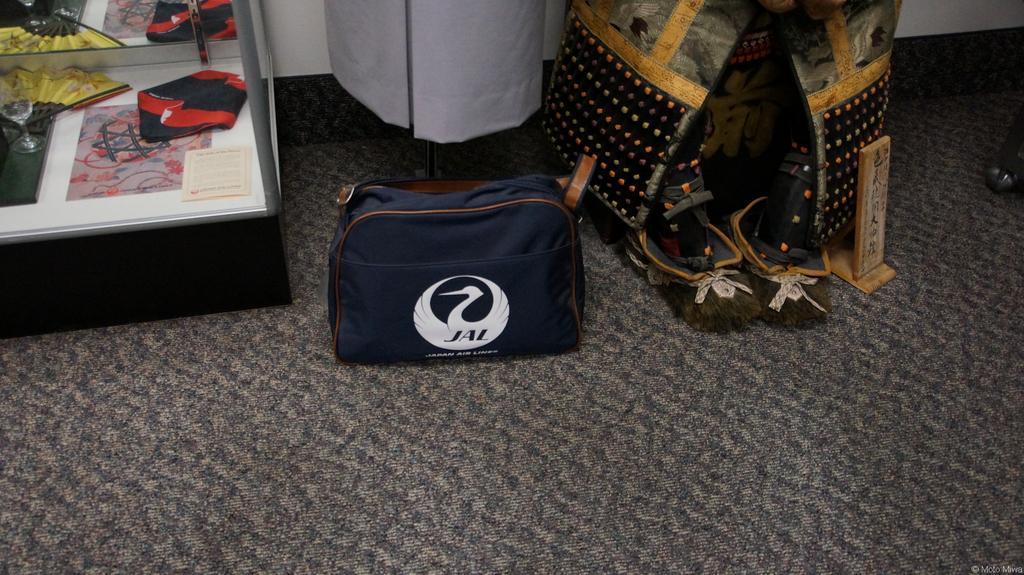In one or two sentences, can you explain what this image depicts? Here we can see a bag on the floor and on the right there is an object and a Japanese samurai armour and a cloth on a stand at the wall. On the left there is a folding fan,cloth and a book on a platform and we can see these reflections on a mirror at the top on the left side. 